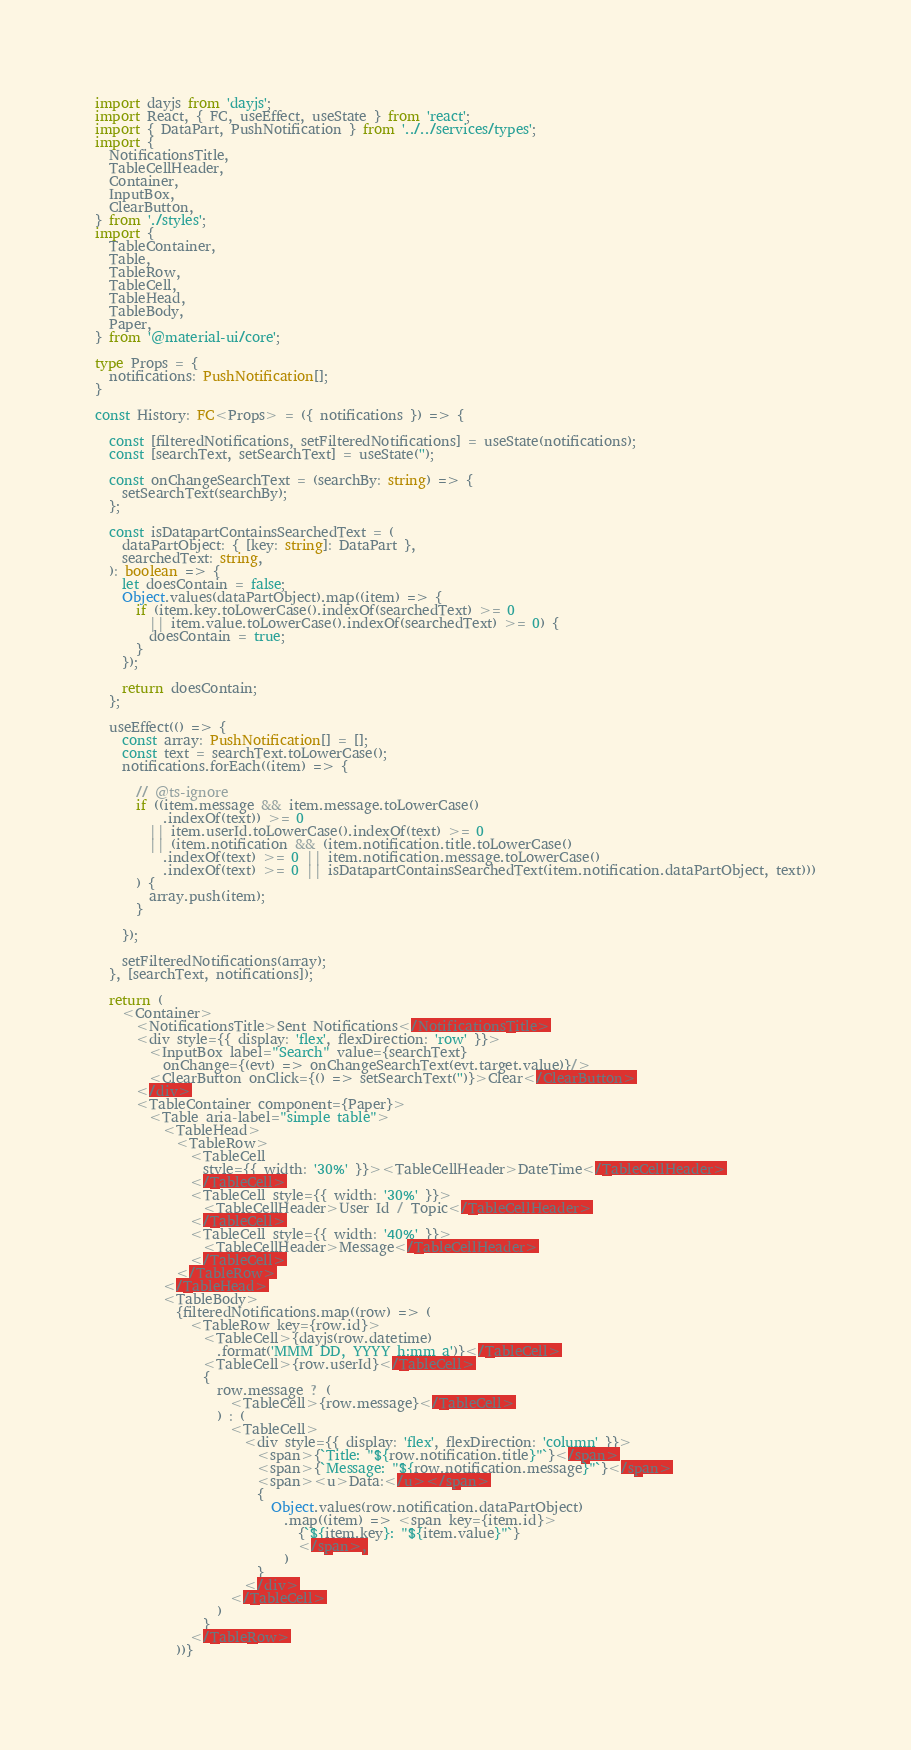Convert code to text. <code><loc_0><loc_0><loc_500><loc_500><_TypeScript_>import dayjs from 'dayjs';
import React, { FC, useEffect, useState } from 'react';
import { DataPart, PushNotification } from '../../services/types';
import {
  NotificationsTitle,
  TableCellHeader,
  Container,
  InputBox,
  ClearButton,
} from './styles';
import {
  TableContainer,
  Table,
  TableRow,
  TableCell,
  TableHead,
  TableBody,
  Paper,
} from '@material-ui/core';

type Props = {
  notifications: PushNotification[];
}

const History: FC<Props> = ({ notifications }) => {

  const [filteredNotifications, setFilteredNotifications] = useState(notifications);
  const [searchText, setSearchText] = useState('');

  const onChangeSearchText = (searchBy: string) => {
    setSearchText(searchBy);
  };

  const isDatapartContainsSearchedText = (
    dataPartObject: { [key: string]: DataPart },
    searchedText: string,
  ): boolean => {
    let doesContain = false;
    Object.values(dataPartObject).map((item) => {
      if (item.key.toLowerCase().indexOf(searchedText) >= 0
        || item.value.toLowerCase().indexOf(searchedText) >= 0) {
        doesContain = true;
      }
    });

    return doesContain;
  };

  useEffect(() => {
    const array: PushNotification[] = [];
    const text = searchText.toLowerCase();
    notifications.forEach((item) => {

      // @ts-ignore
      if ((item.message && item.message.toLowerCase()
          .indexOf(text)) >= 0
        || item.userId.toLowerCase().indexOf(text) >= 0
        || (item.notification && (item.notification.title.toLowerCase()
          .indexOf(text) >= 0 || item.notification.message.toLowerCase()
          .indexOf(text) >= 0 || isDatapartContainsSearchedText(item.notification.dataPartObject, text)))
      ) {
        array.push(item);
      }

    });

    setFilteredNotifications(array);
  }, [searchText, notifications]);

  return (
    <Container>
      <NotificationsTitle>Sent Notifications</NotificationsTitle>
      <div style={{ display: 'flex', flexDirection: 'row' }}>
        <InputBox label="Search" value={searchText}
          onChange={(evt) => onChangeSearchText(evt.target.value)}/>
        <ClearButton onClick={() => setSearchText('')}>Clear</ClearButton>
      </div>
      <TableContainer component={Paper}>
        <Table aria-label="simple table">
          <TableHead>
            <TableRow>
              <TableCell
                style={{ width: '30%' }}><TableCellHeader>DateTime</TableCellHeader>
              </TableCell>
              <TableCell style={{ width: '30%' }}>
                <TableCellHeader>User Id / Topic</TableCellHeader>
              </TableCell>
              <TableCell style={{ width: '40%' }}>
                <TableCellHeader>Message</TableCellHeader>
              </TableCell>
            </TableRow>
          </TableHead>
          <TableBody>
            {filteredNotifications.map((row) => (
              <TableRow key={row.id}>
                <TableCell>{dayjs(row.datetime)
                  .format('MMM DD, YYYY h:mm a')}</TableCell>
                <TableCell>{row.userId}</TableCell>
                {
                  row.message ? (
                    <TableCell>{row.message}</TableCell>
                  ) : (
                    <TableCell>
                      <div style={{ display: 'flex', flexDirection: 'column' }}>
                        <span>{`Title: "${row.notification.title}"`}</span>
                        <span>{`Message: "${row.notification.message}"`}</span>
                        <span><u>Data:</u></span>
                        {
                          Object.values(row.notification.dataPartObject)
                            .map((item) => <span key={item.id}>
                              {`${item.key}: "${item.value}"`}
                              </span>,
                            )
                        }
                      </div>
                    </TableCell>
                  )
                }
              </TableRow>
            ))}</code> 